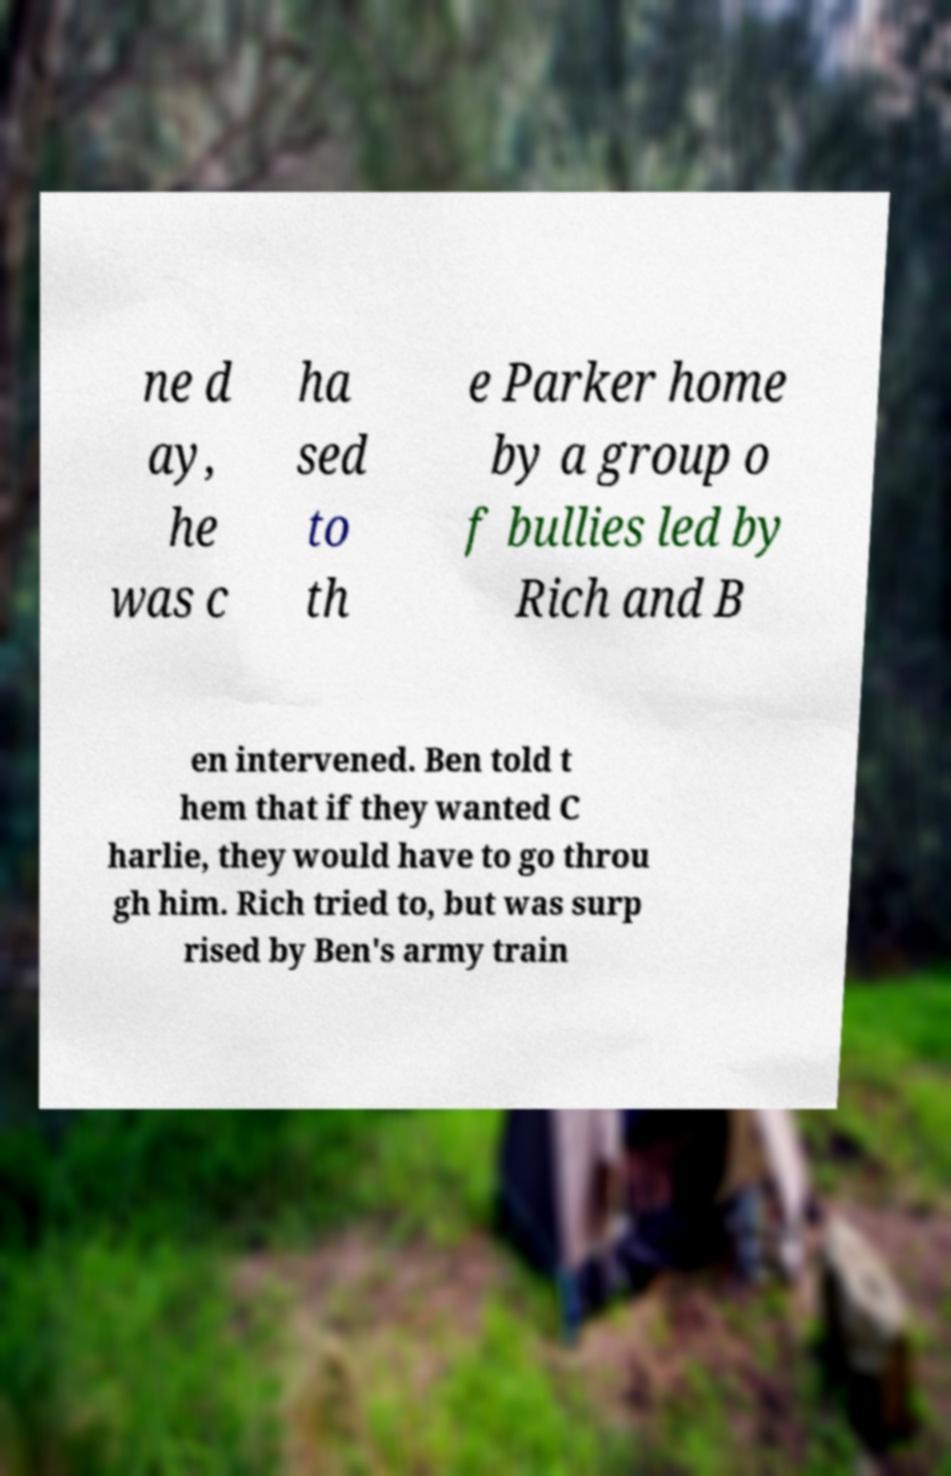For documentation purposes, I need the text within this image transcribed. Could you provide that? ne d ay, he was c ha sed to th e Parker home by a group o f bullies led by Rich and B en intervened. Ben told t hem that if they wanted C harlie, they would have to go throu gh him. Rich tried to, but was surp rised by Ben's army train 